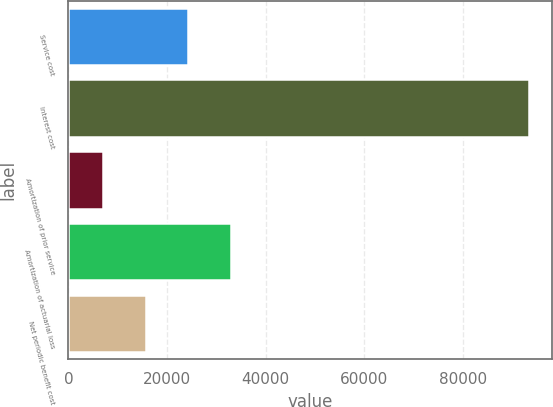Convert chart to OTSL. <chart><loc_0><loc_0><loc_500><loc_500><bar_chart><fcel>Service cost<fcel>Interest cost<fcel>Amortization of prior service<fcel>Amortization of actuarial loss<fcel>Net periodic benefit cost<nl><fcel>24306.6<fcel>93493<fcel>7010<fcel>32954.9<fcel>15658.3<nl></chart> 